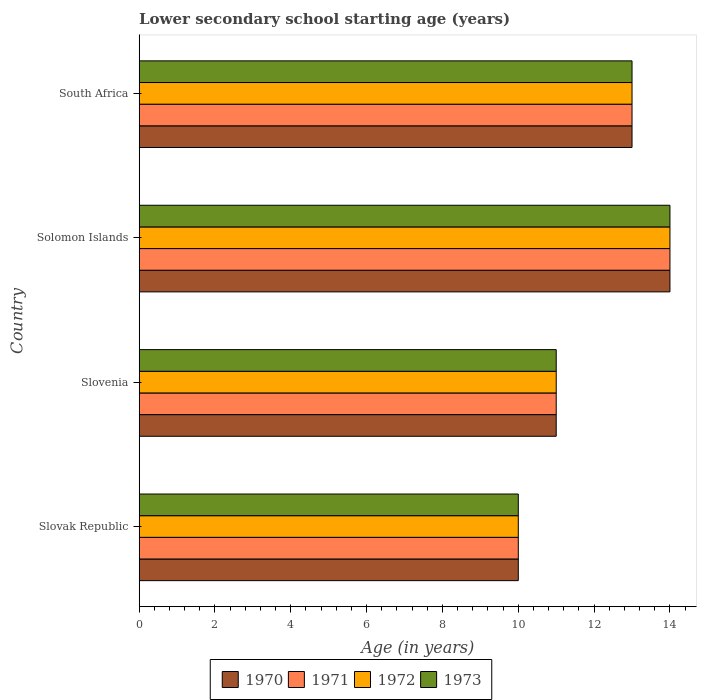Are the number of bars per tick equal to the number of legend labels?
Ensure brevity in your answer.  Yes. What is the label of the 2nd group of bars from the top?
Your response must be concise. Solomon Islands. In how many cases, is the number of bars for a given country not equal to the number of legend labels?
Offer a very short reply. 0. Across all countries, what is the maximum lower secondary school starting age of children in 1971?
Keep it short and to the point. 14. In which country was the lower secondary school starting age of children in 1972 maximum?
Your answer should be very brief. Solomon Islands. In which country was the lower secondary school starting age of children in 1972 minimum?
Provide a succinct answer. Slovak Republic. What is the difference between the lower secondary school starting age of children in 1971 in Solomon Islands and that in South Africa?
Give a very brief answer. 1. What is the difference between the lower secondary school starting age of children in 1973 and lower secondary school starting age of children in 1972 in Slovenia?
Your answer should be very brief. 0. What is the ratio of the lower secondary school starting age of children in 1971 in Slovak Republic to that in South Africa?
Provide a succinct answer. 0.77. Is the lower secondary school starting age of children in 1970 in Slovak Republic less than that in Slovenia?
Give a very brief answer. Yes. Is the difference between the lower secondary school starting age of children in 1973 in Slovenia and South Africa greater than the difference between the lower secondary school starting age of children in 1972 in Slovenia and South Africa?
Keep it short and to the point. No. What is the difference between the highest and the second highest lower secondary school starting age of children in 1973?
Make the answer very short. 1. What is the difference between the highest and the lowest lower secondary school starting age of children in 1972?
Keep it short and to the point. 4. In how many countries, is the lower secondary school starting age of children in 1972 greater than the average lower secondary school starting age of children in 1972 taken over all countries?
Offer a very short reply. 2. What does the 2nd bar from the top in Solomon Islands represents?
Provide a short and direct response. 1972. Is it the case that in every country, the sum of the lower secondary school starting age of children in 1973 and lower secondary school starting age of children in 1972 is greater than the lower secondary school starting age of children in 1970?
Offer a terse response. Yes. Are all the bars in the graph horizontal?
Give a very brief answer. Yes. What is the difference between two consecutive major ticks on the X-axis?
Offer a terse response. 2. Are the values on the major ticks of X-axis written in scientific E-notation?
Give a very brief answer. No. Does the graph contain any zero values?
Make the answer very short. No. Does the graph contain grids?
Your response must be concise. No. How many legend labels are there?
Your answer should be compact. 4. What is the title of the graph?
Provide a succinct answer. Lower secondary school starting age (years). What is the label or title of the X-axis?
Your response must be concise. Age (in years). What is the label or title of the Y-axis?
Offer a terse response. Country. What is the Age (in years) of 1970 in Slovak Republic?
Offer a terse response. 10. What is the Age (in years) in 1973 in Slovak Republic?
Offer a very short reply. 10. What is the Age (in years) of 1973 in Slovenia?
Your answer should be very brief. 11. What is the Age (in years) in 1971 in Solomon Islands?
Your answer should be compact. 14. What is the Age (in years) of 1972 in Solomon Islands?
Give a very brief answer. 14. What is the Age (in years) in 1973 in Solomon Islands?
Keep it short and to the point. 14. What is the Age (in years) in 1970 in South Africa?
Offer a terse response. 13. What is the Age (in years) in 1971 in South Africa?
Provide a succinct answer. 13. What is the Age (in years) in 1973 in South Africa?
Offer a terse response. 13. Across all countries, what is the maximum Age (in years) of 1972?
Your answer should be compact. 14. Across all countries, what is the maximum Age (in years) in 1973?
Give a very brief answer. 14. Across all countries, what is the minimum Age (in years) in 1970?
Give a very brief answer. 10. Across all countries, what is the minimum Age (in years) in 1973?
Provide a short and direct response. 10. What is the total Age (in years) of 1971 in the graph?
Offer a very short reply. 48. What is the total Age (in years) of 1973 in the graph?
Offer a terse response. 48. What is the difference between the Age (in years) in 1973 in Slovak Republic and that in Slovenia?
Keep it short and to the point. -1. What is the difference between the Age (in years) of 1973 in Slovak Republic and that in Solomon Islands?
Ensure brevity in your answer.  -4. What is the difference between the Age (in years) of 1973 in Slovak Republic and that in South Africa?
Ensure brevity in your answer.  -3. What is the difference between the Age (in years) of 1970 in Slovenia and that in Solomon Islands?
Your answer should be compact. -3. What is the difference between the Age (in years) in 1971 in Slovenia and that in South Africa?
Provide a succinct answer. -2. What is the difference between the Age (in years) in 1970 in Solomon Islands and that in South Africa?
Your answer should be compact. 1. What is the difference between the Age (in years) of 1971 in Solomon Islands and that in South Africa?
Ensure brevity in your answer.  1. What is the difference between the Age (in years) of 1973 in Solomon Islands and that in South Africa?
Your answer should be compact. 1. What is the difference between the Age (in years) of 1970 in Slovak Republic and the Age (in years) of 1971 in Slovenia?
Your answer should be compact. -1. What is the difference between the Age (in years) in 1970 in Slovak Republic and the Age (in years) in 1972 in Slovenia?
Your answer should be compact. -1. What is the difference between the Age (in years) in 1972 in Slovak Republic and the Age (in years) in 1973 in Slovenia?
Your answer should be compact. -1. What is the difference between the Age (in years) in 1970 in Slovak Republic and the Age (in years) in 1971 in Solomon Islands?
Give a very brief answer. -4. What is the difference between the Age (in years) in 1970 in Slovak Republic and the Age (in years) in 1973 in Solomon Islands?
Keep it short and to the point. -4. What is the difference between the Age (in years) in 1971 in Slovak Republic and the Age (in years) in 1972 in Solomon Islands?
Your response must be concise. -4. What is the difference between the Age (in years) in 1971 in Slovak Republic and the Age (in years) in 1972 in South Africa?
Give a very brief answer. -3. What is the difference between the Age (in years) in 1971 in Slovak Republic and the Age (in years) in 1973 in South Africa?
Provide a succinct answer. -3. What is the difference between the Age (in years) of 1970 in Slovenia and the Age (in years) of 1971 in Solomon Islands?
Provide a succinct answer. -3. What is the difference between the Age (in years) of 1970 in Slovenia and the Age (in years) of 1972 in Solomon Islands?
Give a very brief answer. -3. What is the difference between the Age (in years) of 1971 in Slovenia and the Age (in years) of 1973 in Solomon Islands?
Your answer should be very brief. -3. What is the difference between the Age (in years) in 1972 in Slovenia and the Age (in years) in 1973 in Solomon Islands?
Offer a terse response. -3. What is the difference between the Age (in years) in 1970 in Slovenia and the Age (in years) in 1972 in South Africa?
Your response must be concise. -2. What is the difference between the Age (in years) of 1971 in Slovenia and the Age (in years) of 1973 in South Africa?
Provide a succinct answer. -2. What is the difference between the Age (in years) in 1972 in Slovenia and the Age (in years) in 1973 in South Africa?
Your answer should be very brief. -2. What is the difference between the Age (in years) in 1970 in Solomon Islands and the Age (in years) in 1973 in South Africa?
Your answer should be compact. 1. What is the difference between the Age (in years) of 1971 in Solomon Islands and the Age (in years) of 1972 in South Africa?
Make the answer very short. 1. What is the average Age (in years) of 1971 per country?
Your response must be concise. 12. What is the average Age (in years) in 1973 per country?
Your answer should be compact. 12. What is the difference between the Age (in years) of 1970 and Age (in years) of 1971 in Slovak Republic?
Your answer should be compact. 0. What is the difference between the Age (in years) of 1970 and Age (in years) of 1973 in Slovak Republic?
Ensure brevity in your answer.  0. What is the difference between the Age (in years) of 1971 and Age (in years) of 1973 in Slovak Republic?
Make the answer very short. 0. What is the difference between the Age (in years) of 1972 and Age (in years) of 1973 in Slovak Republic?
Provide a short and direct response. 0. What is the difference between the Age (in years) in 1970 and Age (in years) in 1971 in Slovenia?
Give a very brief answer. 0. What is the difference between the Age (in years) in 1970 and Age (in years) in 1972 in Slovenia?
Keep it short and to the point. 0. What is the difference between the Age (in years) in 1971 and Age (in years) in 1972 in Slovenia?
Give a very brief answer. 0. What is the difference between the Age (in years) in 1970 and Age (in years) in 1971 in Solomon Islands?
Your answer should be very brief. 0. What is the difference between the Age (in years) in 1970 and Age (in years) in 1972 in Solomon Islands?
Your answer should be compact. 0. What is the difference between the Age (in years) of 1970 and Age (in years) of 1973 in Solomon Islands?
Give a very brief answer. 0. What is the difference between the Age (in years) in 1971 and Age (in years) in 1973 in Solomon Islands?
Ensure brevity in your answer.  0. What is the difference between the Age (in years) in 1972 and Age (in years) in 1973 in Solomon Islands?
Keep it short and to the point. 0. What is the difference between the Age (in years) in 1970 and Age (in years) in 1971 in South Africa?
Your response must be concise. 0. What is the difference between the Age (in years) in 1970 and Age (in years) in 1972 in South Africa?
Give a very brief answer. 0. What is the difference between the Age (in years) of 1970 and Age (in years) of 1973 in South Africa?
Give a very brief answer. 0. What is the difference between the Age (in years) of 1971 and Age (in years) of 1972 in South Africa?
Offer a very short reply. 0. What is the difference between the Age (in years) in 1971 and Age (in years) in 1973 in South Africa?
Keep it short and to the point. 0. What is the difference between the Age (in years) of 1972 and Age (in years) of 1973 in South Africa?
Your answer should be compact. 0. What is the ratio of the Age (in years) in 1970 in Slovak Republic to that in Slovenia?
Your response must be concise. 0.91. What is the ratio of the Age (in years) of 1971 in Slovak Republic to that in Slovenia?
Give a very brief answer. 0.91. What is the ratio of the Age (in years) of 1972 in Slovak Republic to that in Slovenia?
Ensure brevity in your answer.  0.91. What is the ratio of the Age (in years) in 1973 in Slovak Republic to that in Slovenia?
Offer a very short reply. 0.91. What is the ratio of the Age (in years) in 1970 in Slovak Republic to that in Solomon Islands?
Offer a terse response. 0.71. What is the ratio of the Age (in years) of 1973 in Slovak Republic to that in Solomon Islands?
Offer a terse response. 0.71. What is the ratio of the Age (in years) in 1970 in Slovak Republic to that in South Africa?
Your answer should be compact. 0.77. What is the ratio of the Age (in years) in 1971 in Slovak Republic to that in South Africa?
Provide a succinct answer. 0.77. What is the ratio of the Age (in years) of 1972 in Slovak Republic to that in South Africa?
Ensure brevity in your answer.  0.77. What is the ratio of the Age (in years) in 1973 in Slovak Republic to that in South Africa?
Keep it short and to the point. 0.77. What is the ratio of the Age (in years) of 1970 in Slovenia to that in Solomon Islands?
Provide a short and direct response. 0.79. What is the ratio of the Age (in years) in 1971 in Slovenia to that in Solomon Islands?
Give a very brief answer. 0.79. What is the ratio of the Age (in years) in 1972 in Slovenia to that in Solomon Islands?
Offer a very short reply. 0.79. What is the ratio of the Age (in years) of 1973 in Slovenia to that in Solomon Islands?
Provide a succinct answer. 0.79. What is the ratio of the Age (in years) in 1970 in Slovenia to that in South Africa?
Offer a very short reply. 0.85. What is the ratio of the Age (in years) in 1971 in Slovenia to that in South Africa?
Offer a very short reply. 0.85. What is the ratio of the Age (in years) of 1972 in Slovenia to that in South Africa?
Make the answer very short. 0.85. What is the ratio of the Age (in years) of 1973 in Slovenia to that in South Africa?
Provide a short and direct response. 0.85. What is the ratio of the Age (in years) in 1971 in Solomon Islands to that in South Africa?
Give a very brief answer. 1.08. What is the ratio of the Age (in years) in 1972 in Solomon Islands to that in South Africa?
Your response must be concise. 1.08. What is the difference between the highest and the second highest Age (in years) in 1970?
Keep it short and to the point. 1. What is the difference between the highest and the second highest Age (in years) in 1973?
Ensure brevity in your answer.  1. 